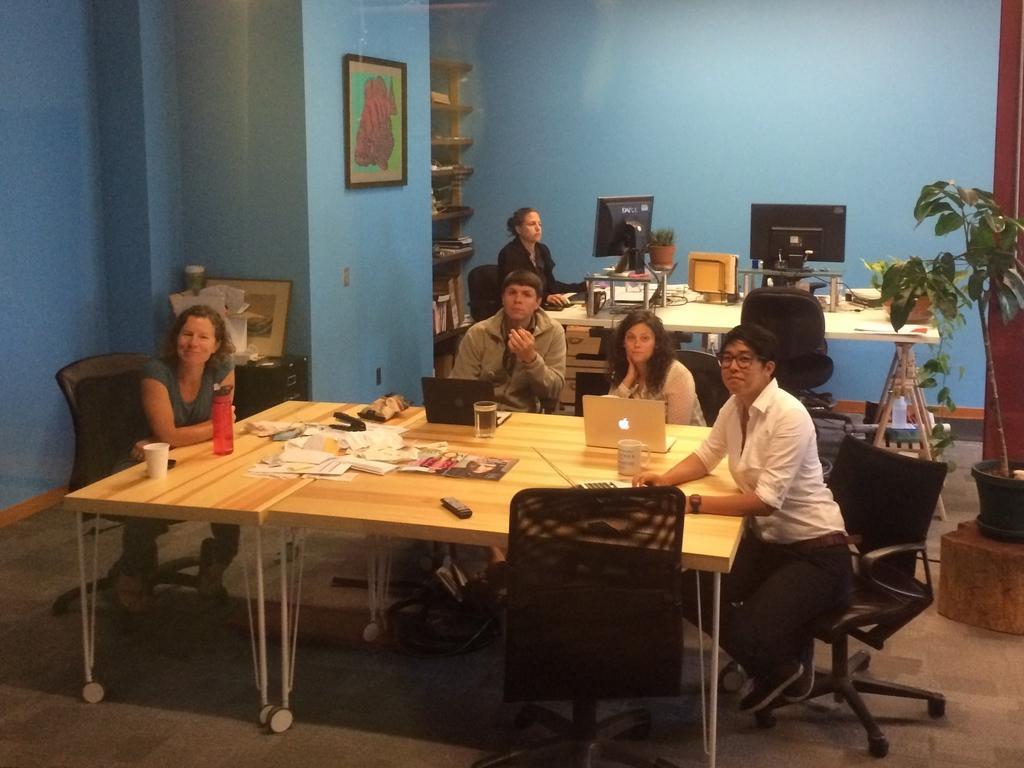How would you summarize this image in a sentence or two? There are four persons sitting in a chair and there is a table in front of them which has laptops and some papers on it and there is another women operating computer in the background. 